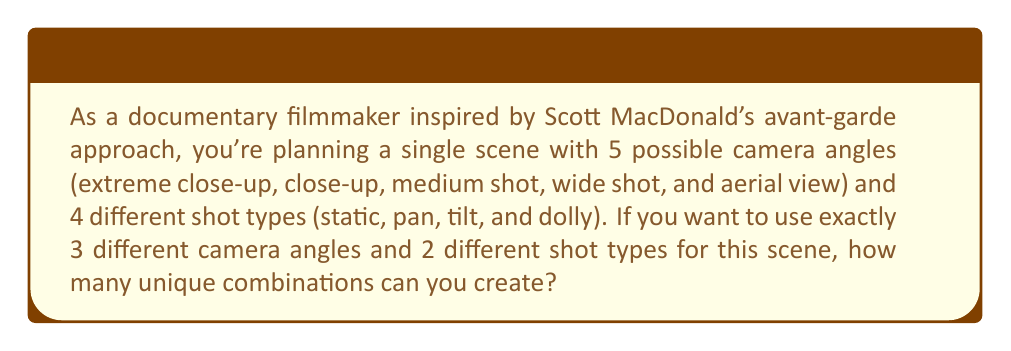Solve this math problem. Let's approach this step-by-step:

1) First, we need to choose 3 camera angles out of 5. This is a combination problem, as the order doesn't matter. We use the formula:

   $$\binom{5}{3} = \frac{5!}{3!(5-3)!} = \frac{5!}{3!2!} = 10$$

2) Next, we need to choose 2 shot types out of 4. Again, this is a combination:

   $$\binom{4}{2} = \frac{4!}{2!(4-2)!} = \frac{4!}{2!2!} = 6$$

3) Now, for each combination of 3 camera angles, we can use any combination of 2 shot types. This is a multiplication principle problem.

4) Therefore, the total number of unique combinations is:

   $$10 \times 6 = 60$$

Thus, you can create 60 unique combinations for your scene, allowing for a variety of creative possibilities in the spirit of Scott MacDonald's experimental approach to filmmaking.
Answer: 60 combinations 